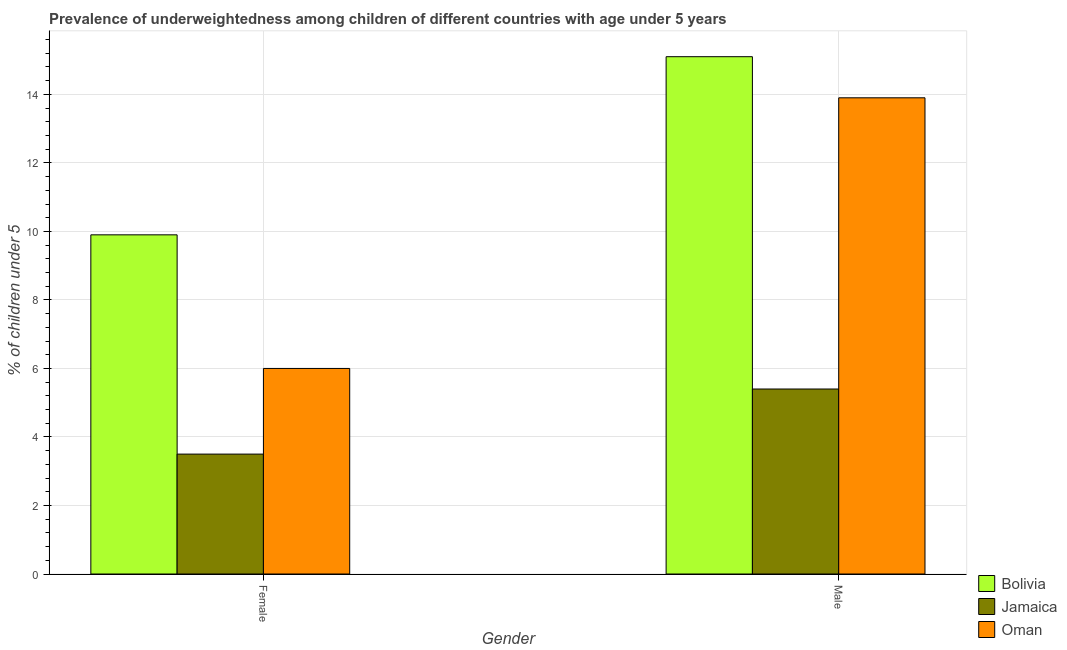How many groups of bars are there?
Keep it short and to the point. 2. Are the number of bars per tick equal to the number of legend labels?
Give a very brief answer. Yes. Are the number of bars on each tick of the X-axis equal?
Offer a very short reply. Yes. How many bars are there on the 1st tick from the left?
Ensure brevity in your answer.  3. How many bars are there on the 1st tick from the right?
Your answer should be compact. 3. What is the percentage of underweighted male children in Oman?
Your answer should be compact. 13.9. Across all countries, what is the maximum percentage of underweighted male children?
Make the answer very short. 15.1. Across all countries, what is the minimum percentage of underweighted male children?
Provide a short and direct response. 5.4. In which country was the percentage of underweighted male children maximum?
Give a very brief answer. Bolivia. In which country was the percentage of underweighted male children minimum?
Your answer should be compact. Jamaica. What is the total percentage of underweighted female children in the graph?
Make the answer very short. 19.4. What is the difference between the percentage of underweighted female children in Jamaica and that in Bolivia?
Ensure brevity in your answer.  -6.4. What is the difference between the percentage of underweighted male children in Oman and the percentage of underweighted female children in Bolivia?
Offer a terse response. 4. What is the average percentage of underweighted female children per country?
Give a very brief answer. 6.47. What is the difference between the percentage of underweighted male children and percentage of underweighted female children in Jamaica?
Ensure brevity in your answer.  1.9. What is the ratio of the percentage of underweighted female children in Jamaica to that in Bolivia?
Offer a very short reply. 0.35. Is the percentage of underweighted female children in Bolivia less than that in Jamaica?
Ensure brevity in your answer.  No. In how many countries, is the percentage of underweighted male children greater than the average percentage of underweighted male children taken over all countries?
Offer a terse response. 2. How many bars are there?
Offer a terse response. 6. How many countries are there in the graph?
Your response must be concise. 3. Are the values on the major ticks of Y-axis written in scientific E-notation?
Make the answer very short. No. Does the graph contain any zero values?
Ensure brevity in your answer.  No. Does the graph contain grids?
Offer a very short reply. Yes. How are the legend labels stacked?
Keep it short and to the point. Vertical. What is the title of the graph?
Provide a succinct answer. Prevalence of underweightedness among children of different countries with age under 5 years. What is the label or title of the Y-axis?
Offer a terse response.  % of children under 5. What is the  % of children under 5 in Bolivia in Female?
Ensure brevity in your answer.  9.9. What is the  % of children under 5 in Oman in Female?
Keep it short and to the point. 6. What is the  % of children under 5 of Bolivia in Male?
Keep it short and to the point. 15.1. What is the  % of children under 5 in Jamaica in Male?
Ensure brevity in your answer.  5.4. What is the  % of children under 5 of Oman in Male?
Your response must be concise. 13.9. Across all Gender, what is the maximum  % of children under 5 of Bolivia?
Your answer should be compact. 15.1. Across all Gender, what is the maximum  % of children under 5 in Jamaica?
Your response must be concise. 5.4. Across all Gender, what is the maximum  % of children under 5 of Oman?
Provide a short and direct response. 13.9. Across all Gender, what is the minimum  % of children under 5 in Bolivia?
Make the answer very short. 9.9. Across all Gender, what is the minimum  % of children under 5 of Jamaica?
Keep it short and to the point. 3.5. Across all Gender, what is the minimum  % of children under 5 in Oman?
Give a very brief answer. 6. What is the total  % of children under 5 of Bolivia in the graph?
Make the answer very short. 25. What is the total  % of children under 5 in Oman in the graph?
Provide a succinct answer. 19.9. What is the difference between the  % of children under 5 of Bolivia in Female and that in Male?
Offer a terse response. -5.2. What is the difference between the  % of children under 5 of Bolivia in Female and the  % of children under 5 of Oman in Male?
Give a very brief answer. -4. What is the average  % of children under 5 in Bolivia per Gender?
Give a very brief answer. 12.5. What is the average  % of children under 5 in Jamaica per Gender?
Give a very brief answer. 4.45. What is the average  % of children under 5 of Oman per Gender?
Provide a short and direct response. 9.95. What is the difference between the  % of children under 5 in Bolivia and  % of children under 5 in Oman in Female?
Your answer should be very brief. 3.9. What is the difference between the  % of children under 5 in Bolivia and  % of children under 5 in Jamaica in Male?
Give a very brief answer. 9.7. What is the ratio of the  % of children under 5 of Bolivia in Female to that in Male?
Provide a short and direct response. 0.66. What is the ratio of the  % of children under 5 of Jamaica in Female to that in Male?
Provide a succinct answer. 0.65. What is the ratio of the  % of children under 5 of Oman in Female to that in Male?
Make the answer very short. 0.43. What is the difference between the highest and the second highest  % of children under 5 of Bolivia?
Offer a terse response. 5.2. What is the difference between the highest and the second highest  % of children under 5 in Jamaica?
Your answer should be compact. 1.9. What is the difference between the highest and the lowest  % of children under 5 of Bolivia?
Give a very brief answer. 5.2. What is the difference between the highest and the lowest  % of children under 5 in Jamaica?
Your answer should be compact. 1.9. 